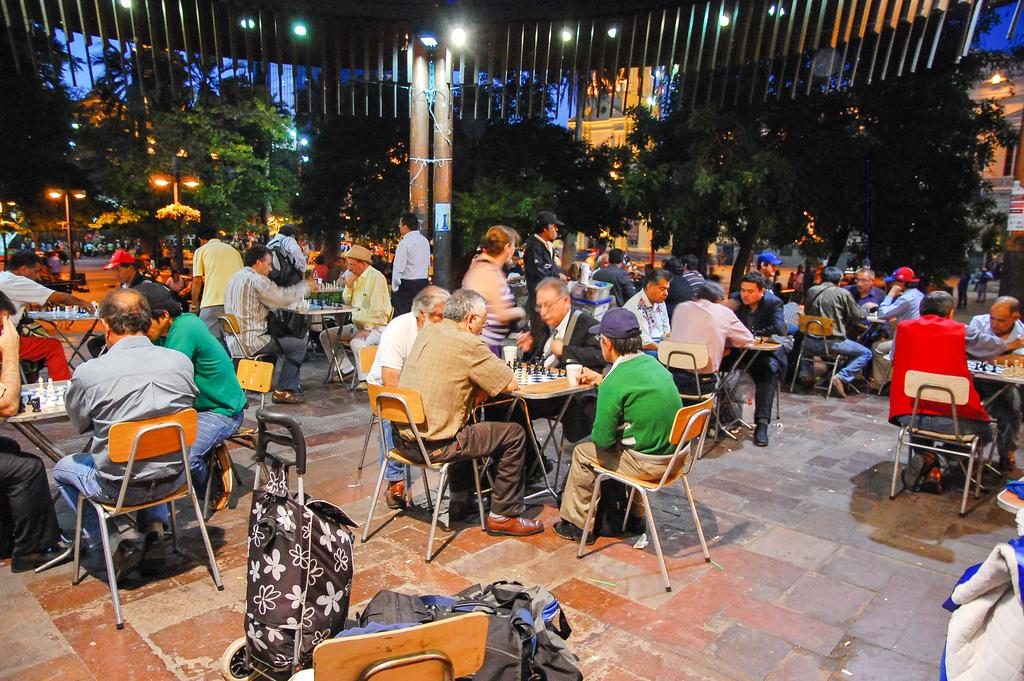How many people are in the image? There is a group of people in the image. What are the people doing in the image? The people are sitting on chairs and playing chess. What is placed in front of the chairs? There are tables in front of the chairs. What can be seen in the background of the image? Light posts, trees, and buildings are visible in the background. What type of clam can be seen crawling on the chessboard in the image? There is no clam present in the image; the people are playing chess on the tables. What smell can be detected from the image? The image does not provide any information about smells, as it is a visual representation. 